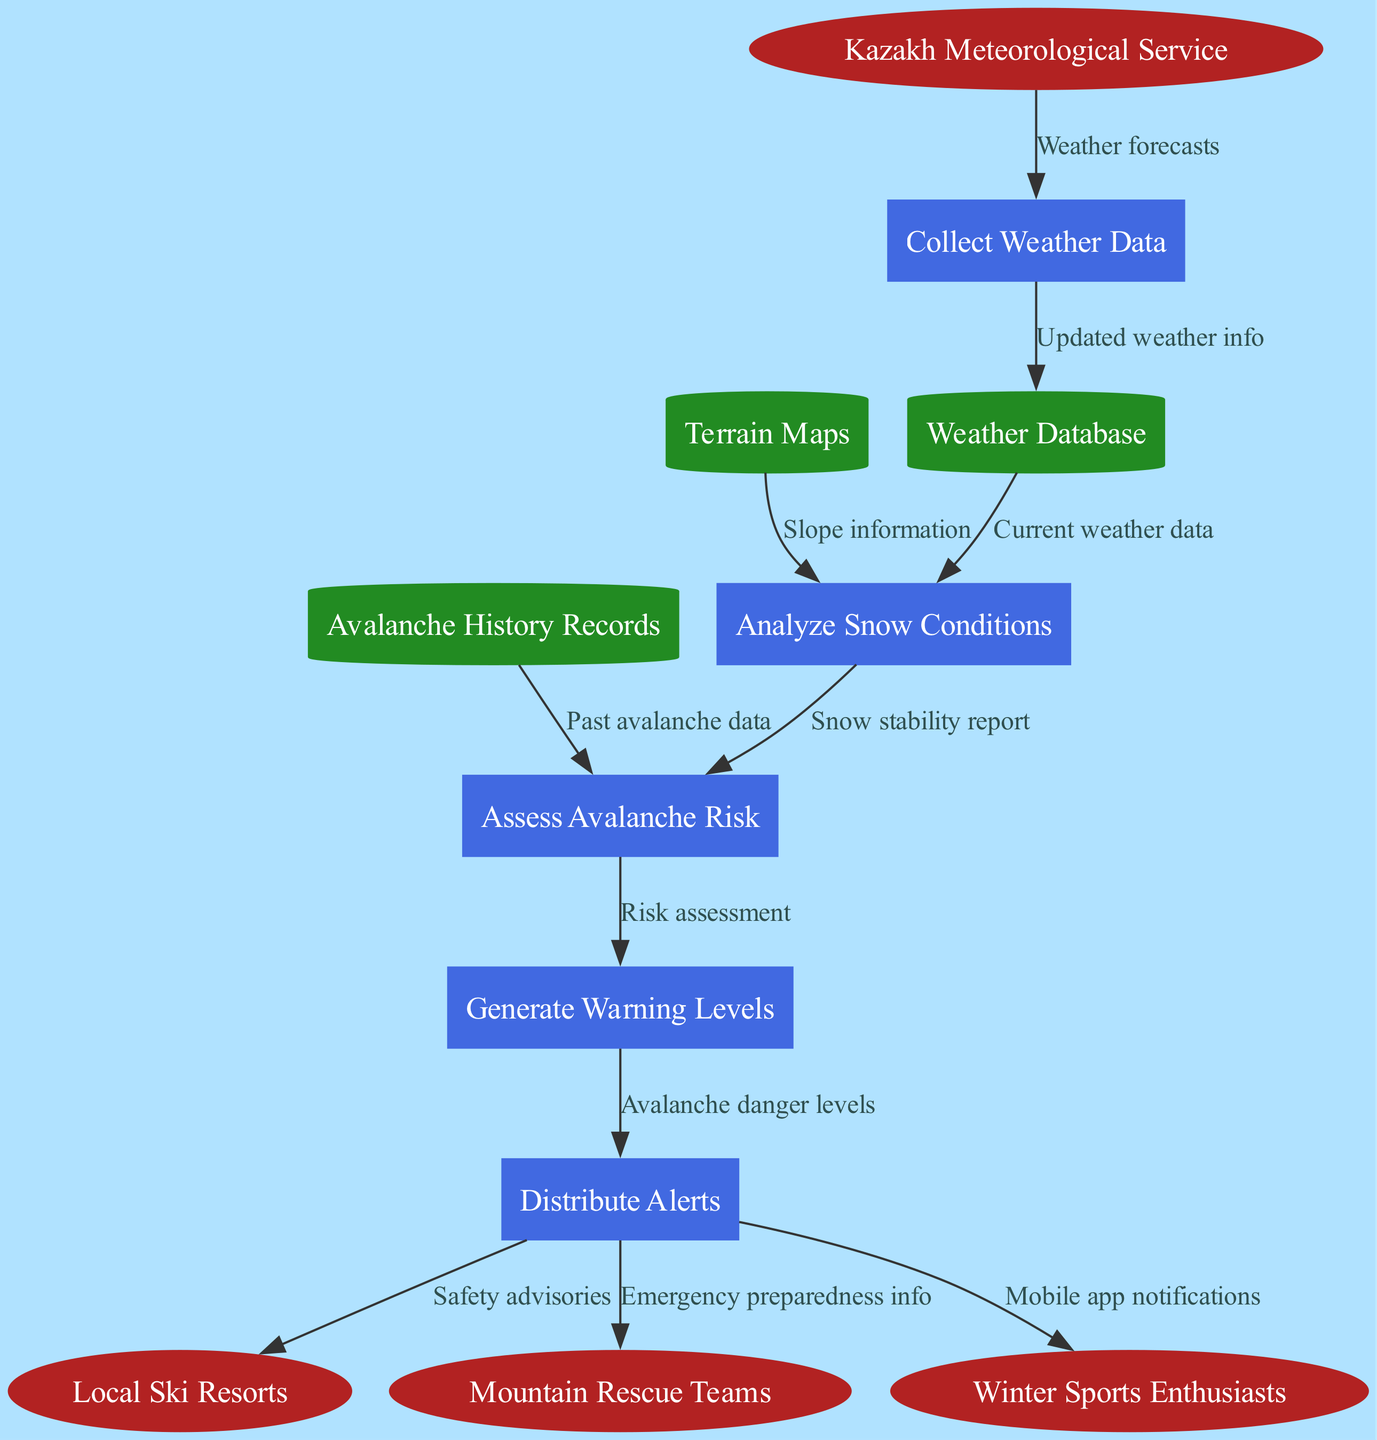What external entity provides weather forecasts? The diagram labels the external entities, and one of them is the Kazakh Meteorological Service, which is responsible for providing weather forecasts.
Answer: Kazakh Meteorological Service How many processes are in the diagram? By counting the processes listed in the diagram, there are five distinct processes: Collect Weather Data, Analyze Snow Conditions, Assess Avalanche Risk, Generate Warning Levels, and Distribute Alerts.
Answer: 5 What is the first process in the flow? The flow begins with the Kazakh Meteorological Service providing weather forecasts to the Collect Weather Data process, indicating that Collect Weather Data is the first process in the sequence.
Answer: Collect Weather Data What data is sent from the Analyze Snow Conditions process to the Assess Avalanche Risk process? The data flow from Analyze Snow Conditions to Assess Avalanche Risk is labeled as "Snow stability report," indicating that this is the information passed along in the diagram.
Answer: Snow stability report What entity receives mobile app notifications? The last flow of alerts is directed to Winter Sports Enthusiasts, which means they are the ones who receive notifications through a mobile app regarding avalanche risks.
Answer: Winter Sports Enthusiasts What is the relationship between the Avalanche History Records and the Assess Avalanche Risk process? The Avalanche History Records provide past avalanche data that is used in the Assess Avalanche Risk process, which evaluates the current risk based on historical records.
Answer: Past avalanche data Which process generates avalanche danger levels? As indicated in the data flow, the Generate Warning Levels process is responsible for generating avalanche danger levels, which are then distributed as safety advisories.
Answer: Generate Warning Levels What type of information is sent to Local Ski Resorts? The alerts dispatched to Local Ski Resorts contain safety advisories, which are crucial for ensuring that skiers and snowboarders are aware of current avalanche risks.
Answer: Safety advisories 